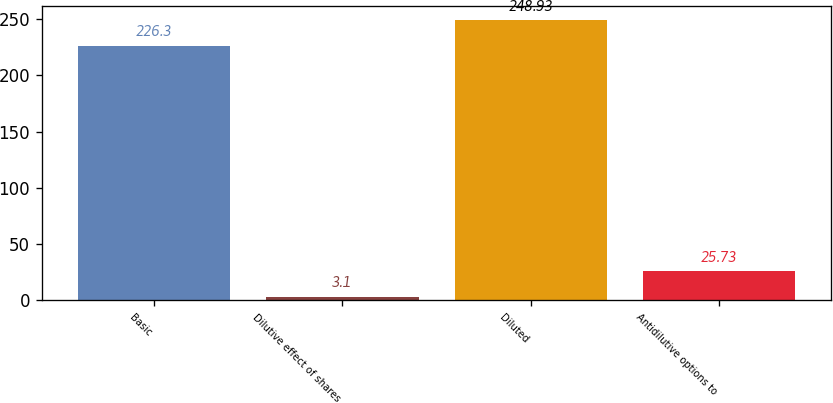Convert chart to OTSL. <chart><loc_0><loc_0><loc_500><loc_500><bar_chart><fcel>Basic<fcel>Dilutive effect of shares<fcel>Diluted<fcel>Antidilutive options to<nl><fcel>226.3<fcel>3.1<fcel>248.93<fcel>25.73<nl></chart> 